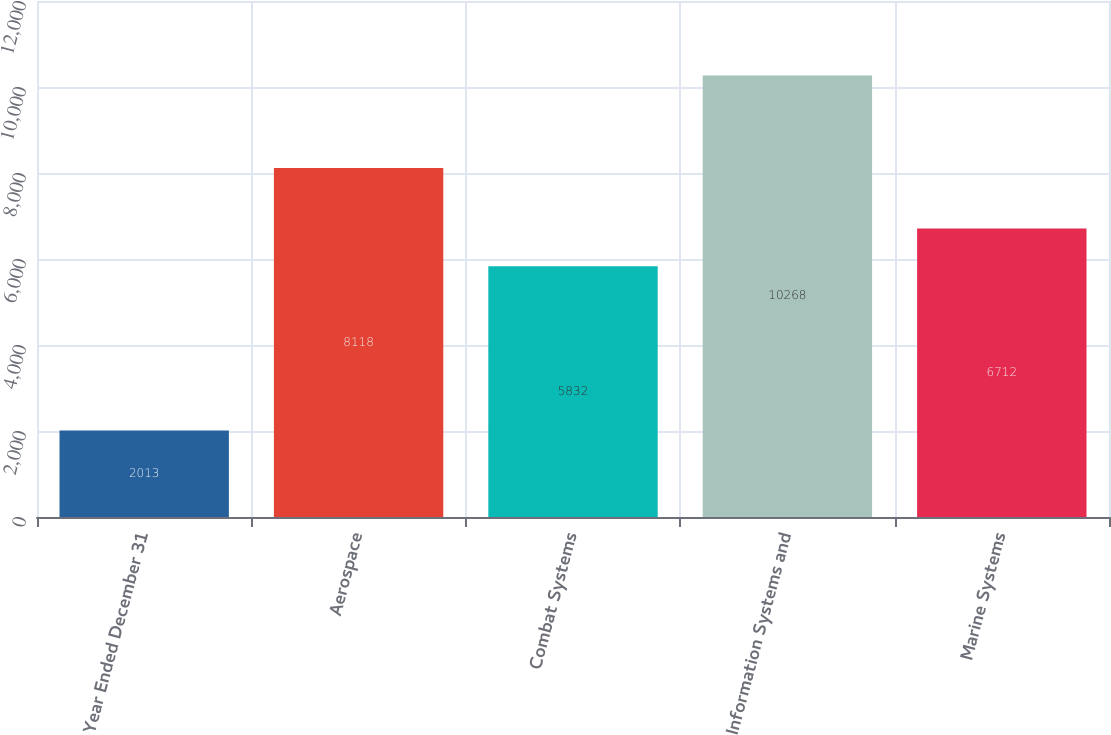<chart> <loc_0><loc_0><loc_500><loc_500><bar_chart><fcel>Year Ended December 31<fcel>Aerospace<fcel>Combat Systems<fcel>Information Systems and<fcel>Marine Systems<nl><fcel>2013<fcel>8118<fcel>5832<fcel>10268<fcel>6712<nl></chart> 